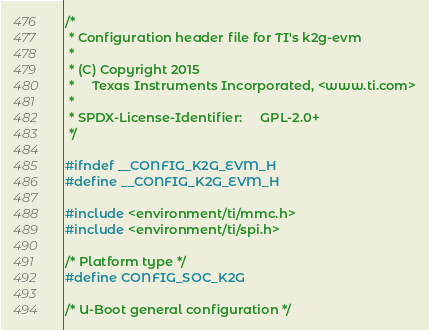Convert code to text. <code><loc_0><loc_0><loc_500><loc_500><_C_>/*
 * Configuration header file for TI's k2g-evm
 *
 * (C) Copyright 2015
 *     Texas Instruments Incorporated, <www.ti.com>
 *
 * SPDX-License-Identifier:     GPL-2.0+
 */

#ifndef __CONFIG_K2G_EVM_H
#define __CONFIG_K2G_EVM_H

#include <environment/ti/mmc.h>
#include <environment/ti/spi.h>

/* Platform type */
#define CONFIG_SOC_K2G

/* U-Boot general configuration */</code> 